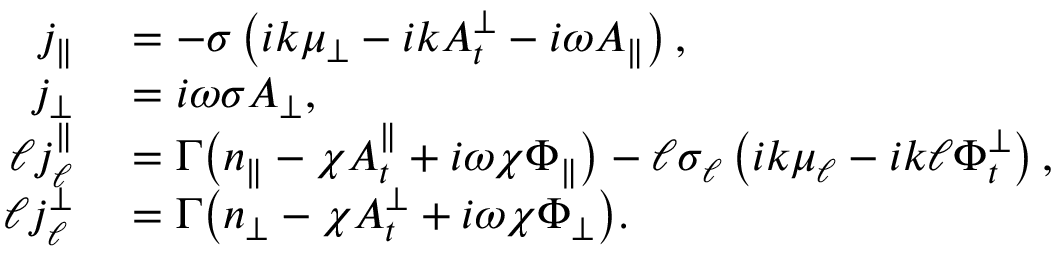Convert formula to latex. <formula><loc_0><loc_0><loc_500><loc_500>\begin{array} { r l } { j _ { \| } } & = - \sigma \left ( i k { \mu _ { \perp } } - i k A _ { t } ^ { \perp } - i \omega A _ { \| } \right ) , } \\ { j _ { \perp } } & = i \omega \sigma A _ { \perp } , } \\ { \ell j _ { \ell } ^ { \| } } & = \Gamma \left ( n _ { \| } - \chi A _ { t } ^ { \| } + i \omega \chi \Phi _ { \| } \right ) - \ell \sigma _ { \ell } \left ( i k \mu _ { \ell } - i k \ell \Phi _ { t } ^ { \perp } \right ) , } \\ { \ell j _ { \ell } ^ { \perp } } & = \Gamma \left ( n _ { \perp } - \chi A _ { t } ^ { \perp } + i \omega \chi \Phi _ { \perp } \right ) . } \end{array}</formula> 